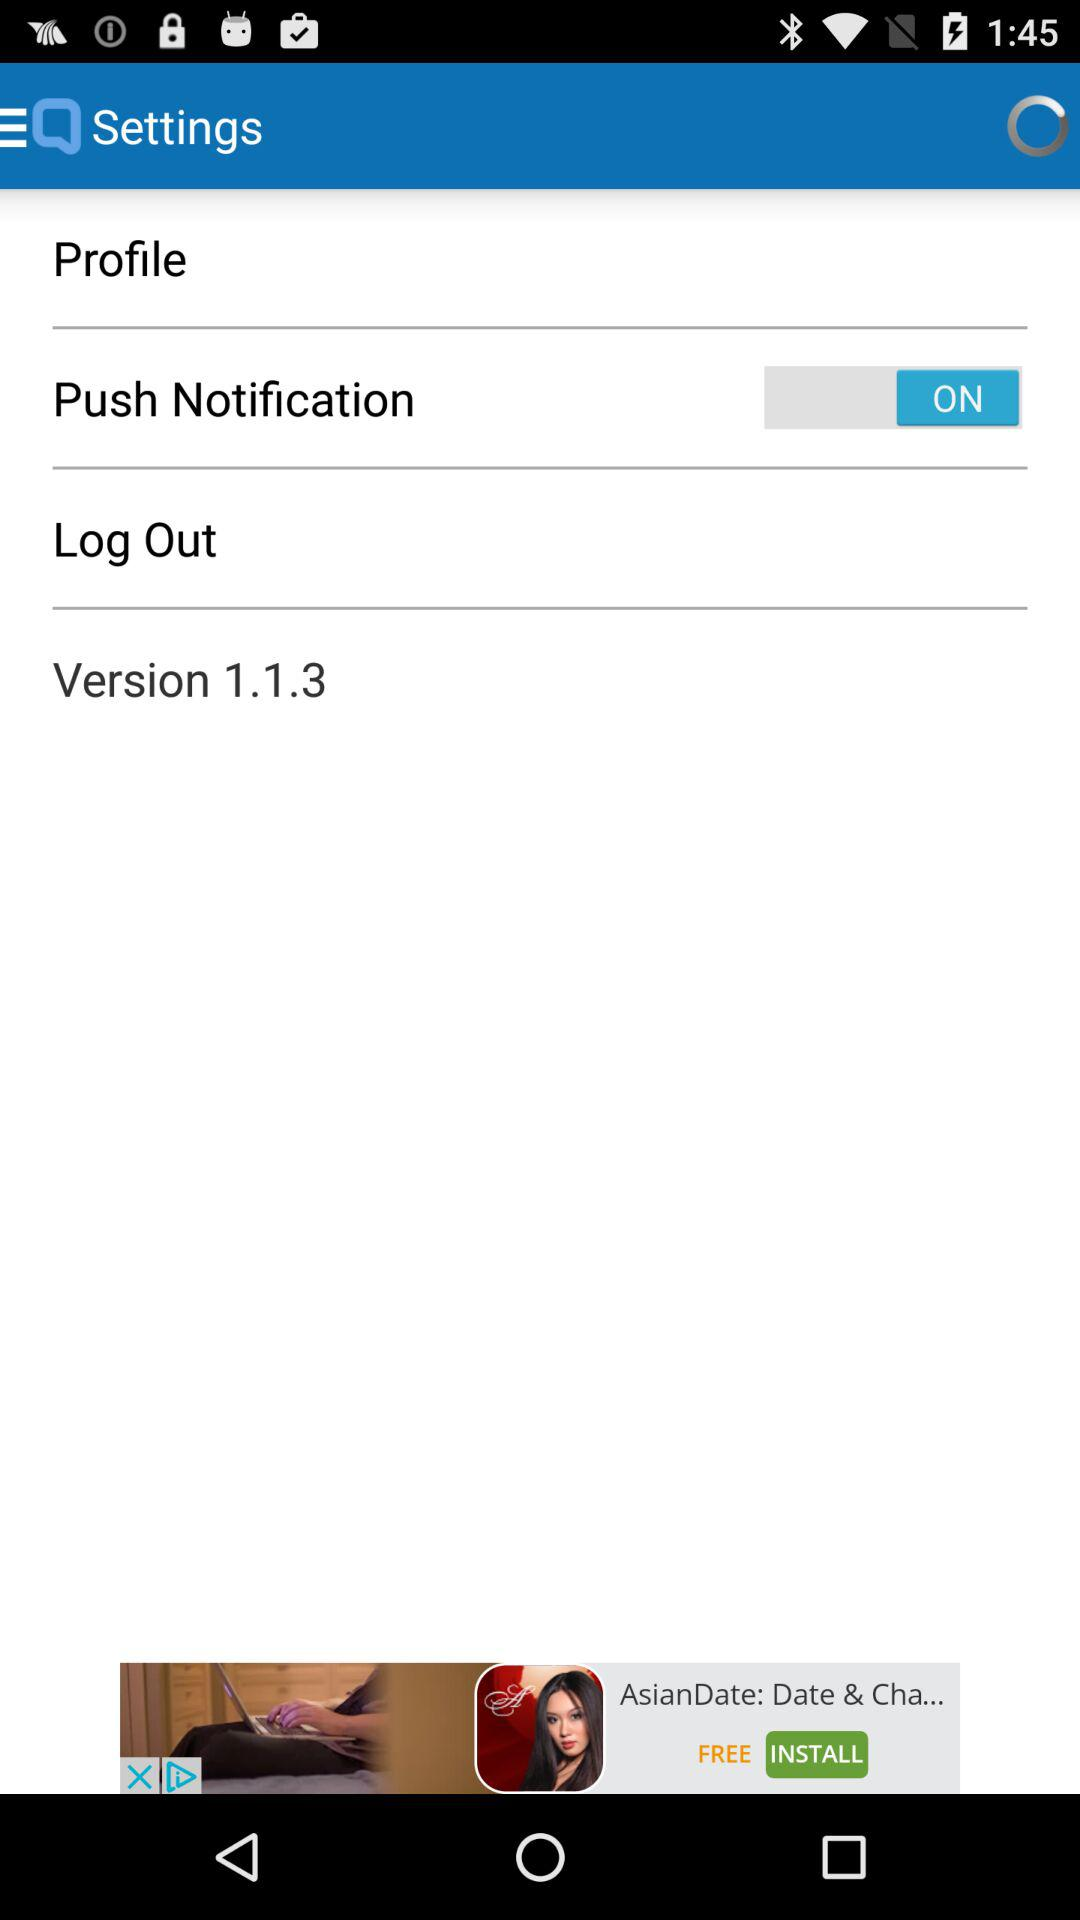What is the status of the "Push Notification"? The status of the "Push Notification" is "ON". 